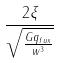Convert formula to latex. <formula><loc_0><loc_0><loc_500><loc_500>\frac { 2 \xi } { \sqrt { \frac { G q _ { f u x } } { w ^ { 3 } } } }</formula> 